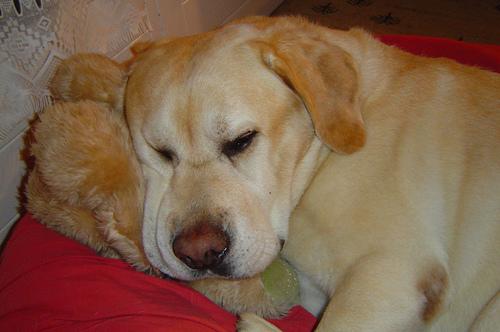What is the puppy resting on?
Answer briefly. Stuffed animal. Is this a cat?
Concise answer only. No. Is this puppy acting hyper?
Concise answer only. No. 